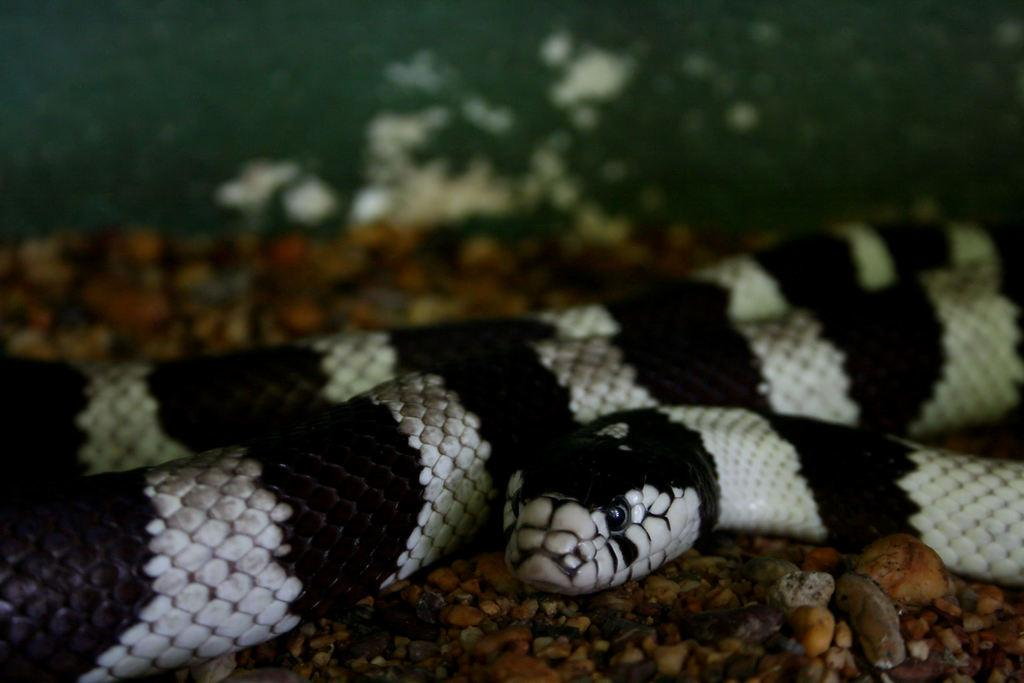What type of animal is present in the image? There is a snake in the image. What is the snake resting on in the image? The snake is on the surface of rocks. What type of doll is sitting next to the mailbox in the image? There is no doll or mailbox present in the image; it only features a snake on rocks. 